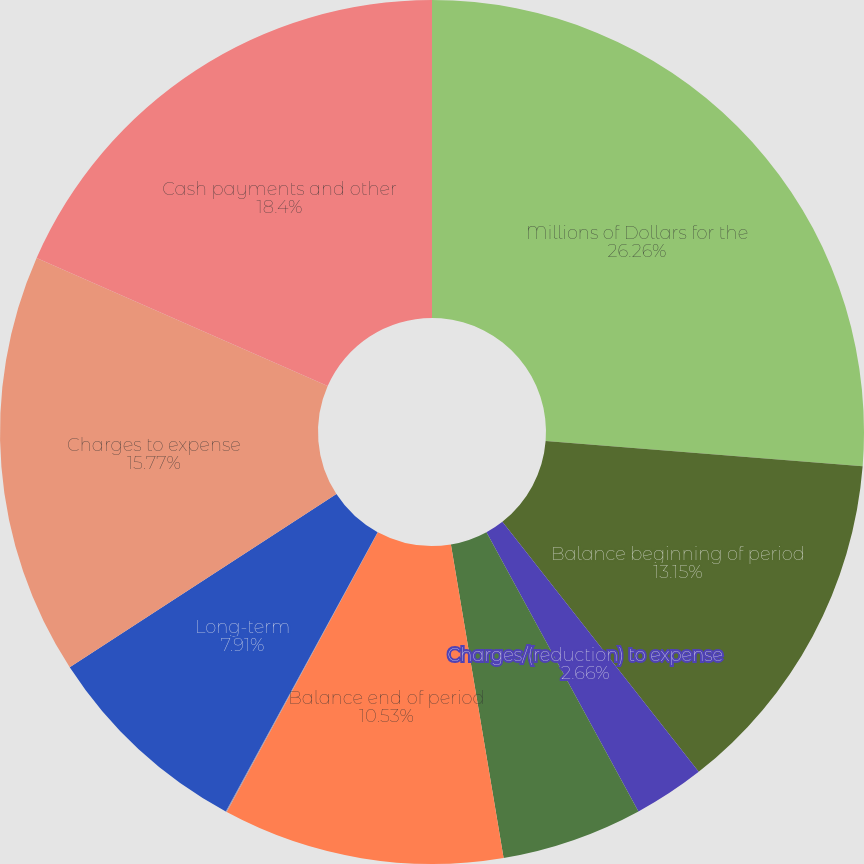<chart> <loc_0><loc_0><loc_500><loc_500><pie_chart><fcel>Millions of Dollars for the<fcel>Balance beginning of period<fcel>Charges/(reduction) to expense<fcel>Net recoveries/(write-offs)<fcel>Balance end of period<fcel>Current<fcel>Long-term<fcel>Charges to expense<fcel>Cash payments and other<nl><fcel>26.26%<fcel>13.15%<fcel>2.66%<fcel>5.28%<fcel>10.53%<fcel>0.04%<fcel>7.91%<fcel>15.77%<fcel>18.4%<nl></chart> 